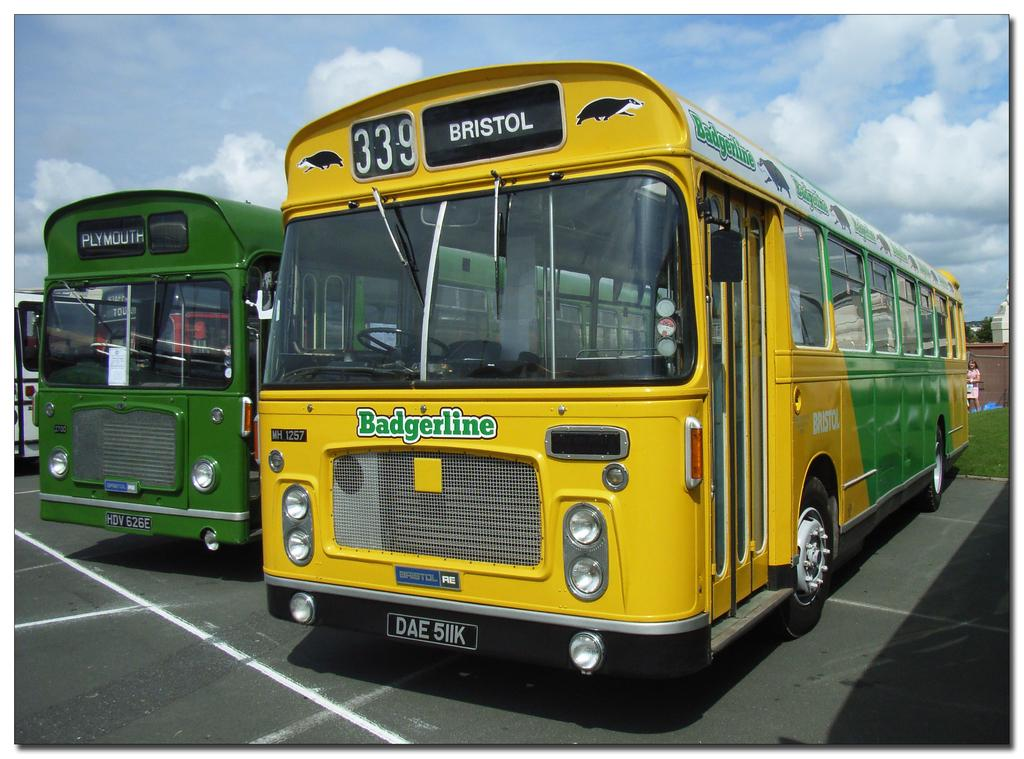What is located in the foreground of the picture? There are buses in the foreground of the picture. What can be seen in the background of the picture? Buildings, trees, a wall, and a person are visible in the background of the picture. What type of vegetation is present in the background of the picture? Trees and grass are visible in the background of the picture. What is the weather like in the image? The sky is sunny in the image. How many pigs are visible in the background of the picture? There are no pigs present in the image. What type of beast is interacting with the person in the background of the picture? There is no beast present in the image; only a person is visible in the background. 